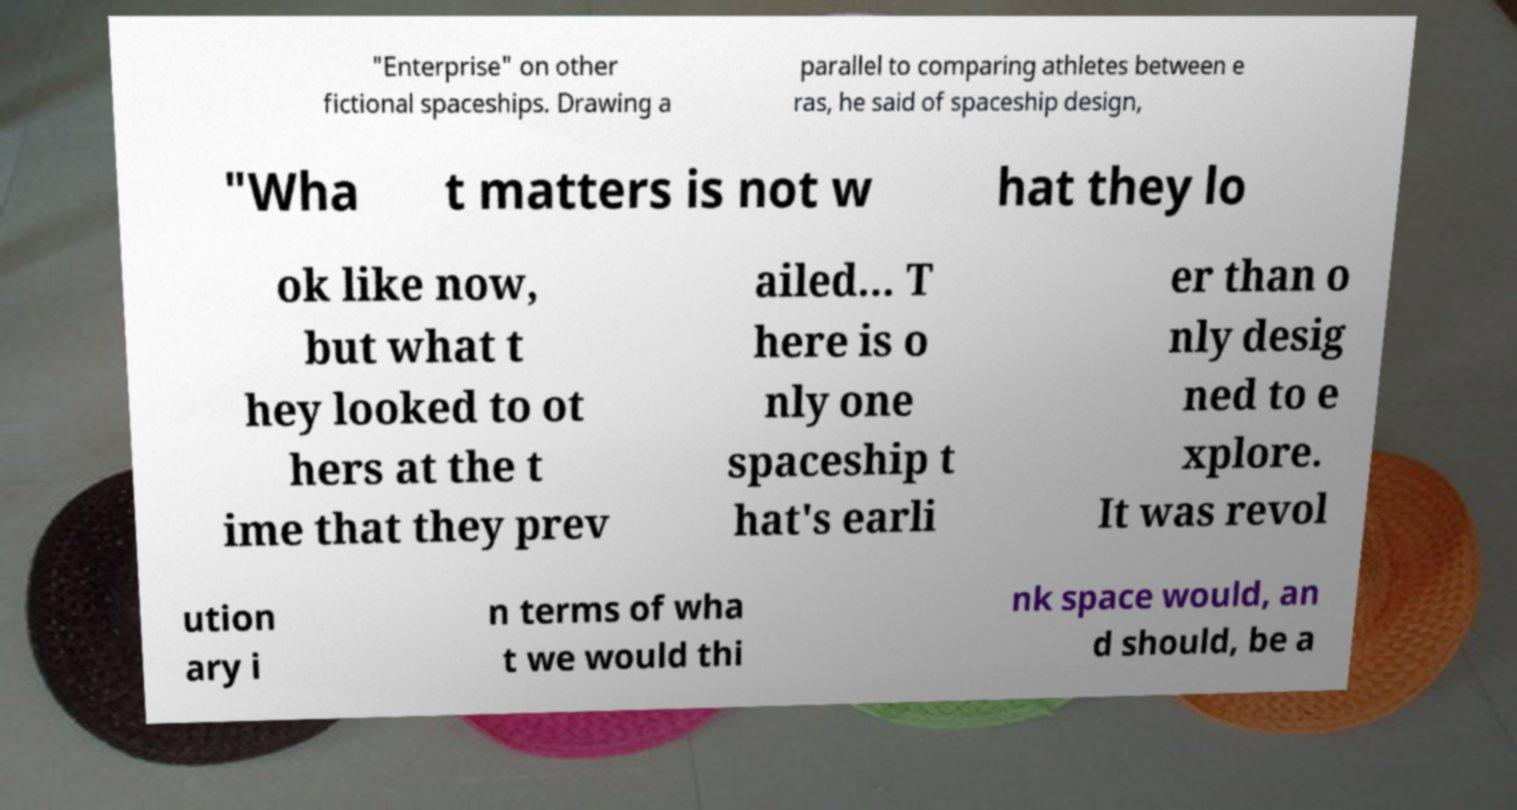Can you read and provide the text displayed in the image?This photo seems to have some interesting text. Can you extract and type it out for me? "Enterprise" on other fictional spaceships. Drawing a parallel to comparing athletes between e ras, he said of spaceship design, "Wha t matters is not w hat they lo ok like now, but what t hey looked to ot hers at the t ime that they prev ailed... T here is o nly one spaceship t hat's earli er than o nly desig ned to e xplore. It was revol ution ary i n terms of wha t we would thi nk space would, an d should, be a 